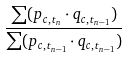<formula> <loc_0><loc_0><loc_500><loc_500>\frac { \sum ( p _ { c , t _ { n } } \cdot q _ { c , t _ { n - 1 } } ) } { \sum ( p _ { c , t _ { n - 1 } } \cdot q _ { c , t _ { n - 1 } } ) }</formula> 